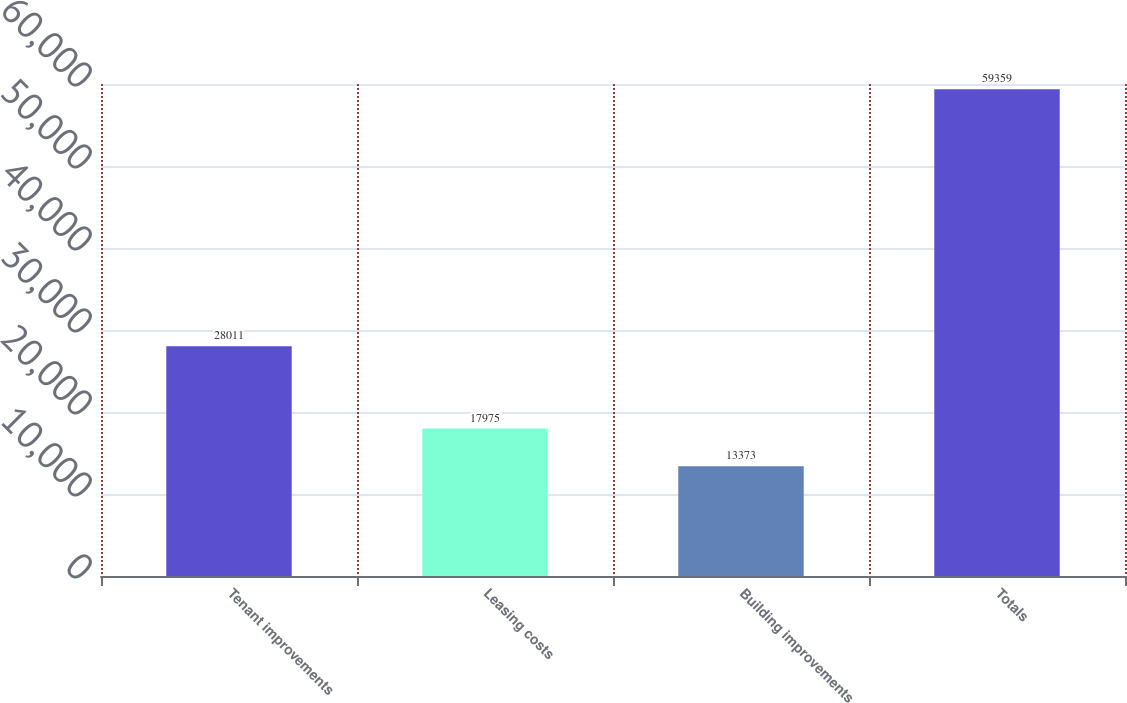Convert chart to OTSL. <chart><loc_0><loc_0><loc_500><loc_500><bar_chart><fcel>Tenant improvements<fcel>Leasing costs<fcel>Building improvements<fcel>Totals<nl><fcel>28011<fcel>17975<fcel>13373<fcel>59359<nl></chart> 